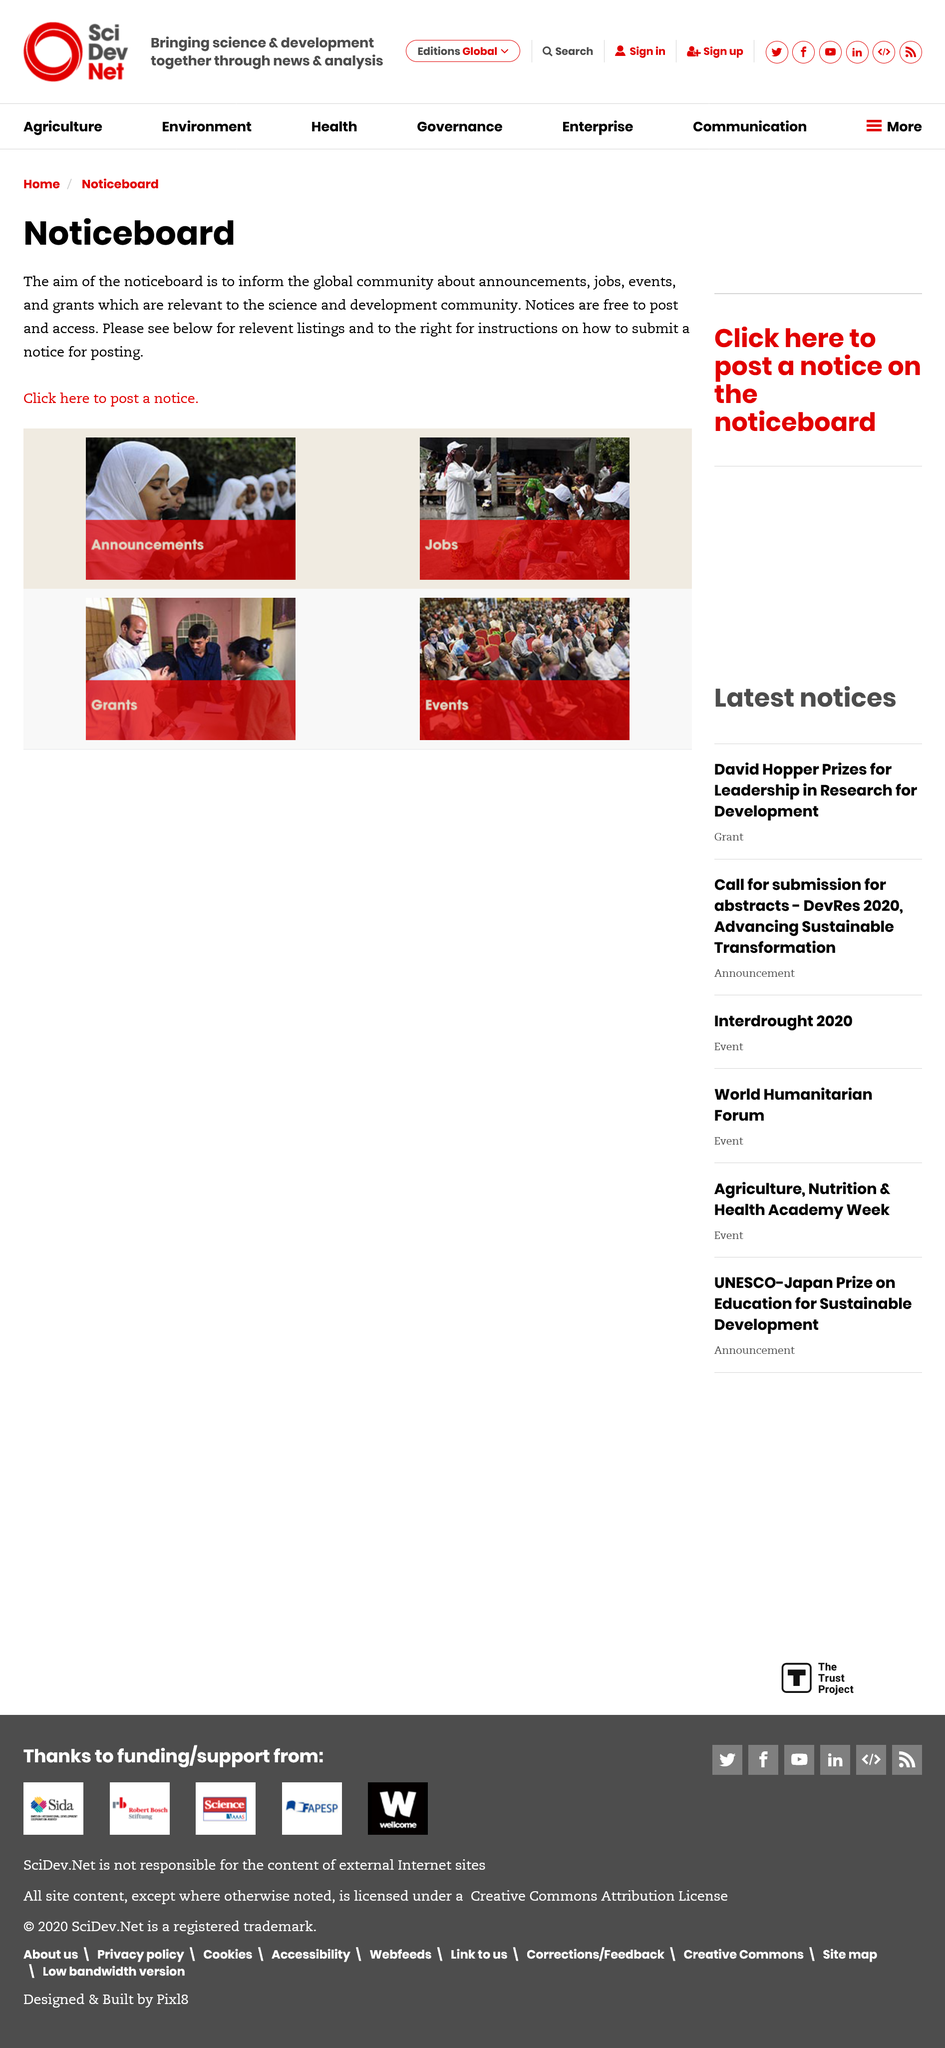Give some essential details in this illustration. The Noticeboard aims to provide information to the global community about announcements, jobs, events, and grants that are relevant to the science and development community. It is recommended that you look to the right for instructions on how to submit a notice for posting. Notices are free to post and access. 